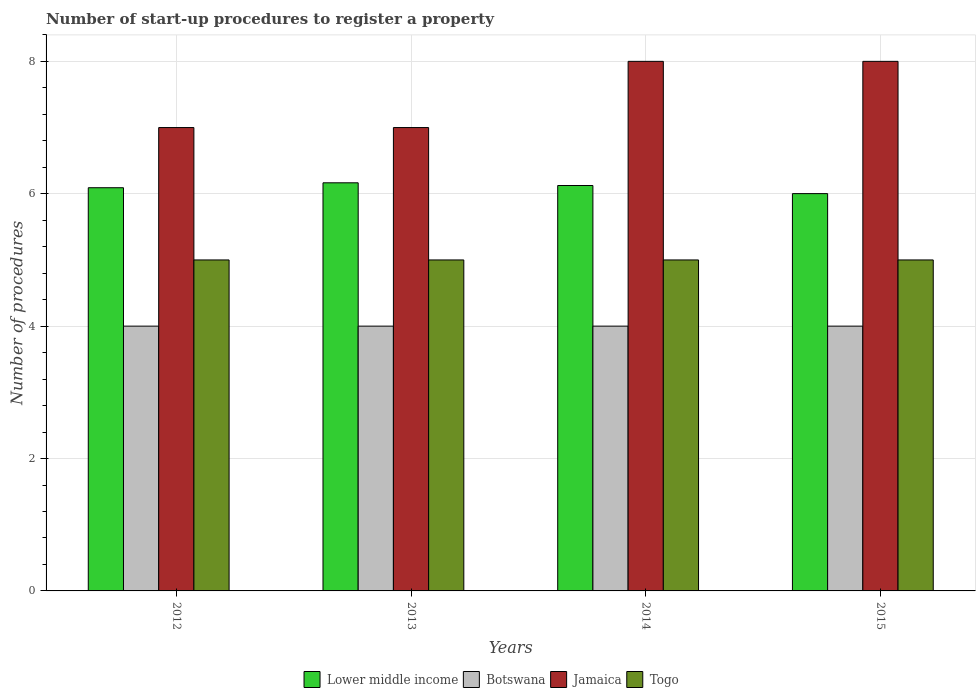How many different coloured bars are there?
Keep it short and to the point. 4. How many groups of bars are there?
Your answer should be compact. 4. Are the number of bars per tick equal to the number of legend labels?
Make the answer very short. Yes. Are the number of bars on each tick of the X-axis equal?
Provide a short and direct response. Yes. How many bars are there on the 2nd tick from the right?
Keep it short and to the point. 4. What is the label of the 1st group of bars from the left?
Your answer should be compact. 2012. What is the number of procedures required to register a property in Togo in 2015?
Keep it short and to the point. 5. Across all years, what is the maximum number of procedures required to register a property in Jamaica?
Provide a succinct answer. 8. Across all years, what is the minimum number of procedures required to register a property in Botswana?
Make the answer very short. 4. In which year was the number of procedures required to register a property in Togo minimum?
Your answer should be very brief. 2012. What is the total number of procedures required to register a property in Lower middle income in the graph?
Give a very brief answer. 24.38. What is the difference between the number of procedures required to register a property in Botswana in 2014 and that in 2015?
Ensure brevity in your answer.  0. What is the difference between the number of procedures required to register a property in Jamaica in 2014 and the number of procedures required to register a property in Botswana in 2013?
Your answer should be very brief. 4. What is the average number of procedures required to register a property in Togo per year?
Keep it short and to the point. 5. In the year 2013, what is the difference between the number of procedures required to register a property in Lower middle income and number of procedures required to register a property in Togo?
Give a very brief answer. 1.17. What is the ratio of the number of procedures required to register a property in Lower middle income in 2012 to that in 2014?
Provide a succinct answer. 0.99. Is the difference between the number of procedures required to register a property in Lower middle income in 2012 and 2013 greater than the difference between the number of procedures required to register a property in Togo in 2012 and 2013?
Offer a very short reply. No. What is the difference between the highest and the second highest number of procedures required to register a property in Botswana?
Keep it short and to the point. 0. What is the difference between the highest and the lowest number of procedures required to register a property in Lower middle income?
Your answer should be compact. 0.16. Is it the case that in every year, the sum of the number of procedures required to register a property in Togo and number of procedures required to register a property in Lower middle income is greater than the sum of number of procedures required to register a property in Jamaica and number of procedures required to register a property in Botswana?
Provide a succinct answer. Yes. What does the 2nd bar from the left in 2015 represents?
Ensure brevity in your answer.  Botswana. What does the 3rd bar from the right in 2012 represents?
Provide a short and direct response. Botswana. Is it the case that in every year, the sum of the number of procedures required to register a property in Togo and number of procedures required to register a property in Lower middle income is greater than the number of procedures required to register a property in Botswana?
Provide a short and direct response. Yes. How many years are there in the graph?
Provide a succinct answer. 4. Are the values on the major ticks of Y-axis written in scientific E-notation?
Make the answer very short. No. Does the graph contain any zero values?
Offer a terse response. No. Where does the legend appear in the graph?
Offer a very short reply. Bottom center. How many legend labels are there?
Offer a terse response. 4. What is the title of the graph?
Your answer should be compact. Number of start-up procedures to register a property. What is the label or title of the X-axis?
Make the answer very short. Years. What is the label or title of the Y-axis?
Offer a terse response. Number of procedures. What is the Number of procedures in Lower middle income in 2012?
Provide a short and direct response. 6.09. What is the Number of procedures of Togo in 2012?
Offer a very short reply. 5. What is the Number of procedures in Lower middle income in 2013?
Offer a terse response. 6.17. What is the Number of procedures in Botswana in 2013?
Your answer should be very brief. 4. What is the Number of procedures of Jamaica in 2013?
Offer a terse response. 7. What is the Number of procedures in Lower middle income in 2014?
Your response must be concise. 6.12. What is the Number of procedures in Botswana in 2014?
Keep it short and to the point. 4. What is the Number of procedures of Togo in 2014?
Offer a very short reply. 5. What is the Number of procedures in Lower middle income in 2015?
Offer a very short reply. 6. What is the Number of procedures in Togo in 2015?
Offer a terse response. 5. Across all years, what is the maximum Number of procedures of Lower middle income?
Your response must be concise. 6.17. Across all years, what is the maximum Number of procedures of Botswana?
Make the answer very short. 4. Across all years, what is the maximum Number of procedures in Togo?
Your response must be concise. 5. Across all years, what is the minimum Number of procedures of Lower middle income?
Your answer should be compact. 6. What is the total Number of procedures in Lower middle income in the graph?
Your answer should be very brief. 24.38. What is the total Number of procedures of Botswana in the graph?
Provide a short and direct response. 16. What is the total Number of procedures of Togo in the graph?
Keep it short and to the point. 20. What is the difference between the Number of procedures in Lower middle income in 2012 and that in 2013?
Your answer should be compact. -0.07. What is the difference between the Number of procedures of Jamaica in 2012 and that in 2013?
Your answer should be compact. 0. What is the difference between the Number of procedures of Lower middle income in 2012 and that in 2014?
Offer a very short reply. -0.03. What is the difference between the Number of procedures in Botswana in 2012 and that in 2014?
Ensure brevity in your answer.  0. What is the difference between the Number of procedures in Togo in 2012 and that in 2014?
Your answer should be compact. 0. What is the difference between the Number of procedures of Lower middle income in 2012 and that in 2015?
Your answer should be compact. 0.09. What is the difference between the Number of procedures of Botswana in 2012 and that in 2015?
Your answer should be very brief. 0. What is the difference between the Number of procedures of Jamaica in 2012 and that in 2015?
Your answer should be very brief. -1. What is the difference between the Number of procedures of Togo in 2012 and that in 2015?
Make the answer very short. 0. What is the difference between the Number of procedures of Lower middle income in 2013 and that in 2014?
Offer a terse response. 0.04. What is the difference between the Number of procedures in Botswana in 2013 and that in 2014?
Your answer should be very brief. 0. What is the difference between the Number of procedures of Jamaica in 2013 and that in 2014?
Provide a short and direct response. -1. What is the difference between the Number of procedures in Lower middle income in 2013 and that in 2015?
Give a very brief answer. 0.16. What is the difference between the Number of procedures in Botswana in 2013 and that in 2015?
Offer a terse response. 0. What is the difference between the Number of procedures of Lower middle income in 2014 and that in 2015?
Offer a terse response. 0.12. What is the difference between the Number of procedures of Botswana in 2014 and that in 2015?
Offer a terse response. 0. What is the difference between the Number of procedures of Jamaica in 2014 and that in 2015?
Make the answer very short. 0. What is the difference between the Number of procedures in Togo in 2014 and that in 2015?
Offer a terse response. 0. What is the difference between the Number of procedures in Lower middle income in 2012 and the Number of procedures in Botswana in 2013?
Offer a very short reply. 2.09. What is the difference between the Number of procedures of Lower middle income in 2012 and the Number of procedures of Jamaica in 2013?
Offer a very short reply. -0.91. What is the difference between the Number of procedures in Lower middle income in 2012 and the Number of procedures in Togo in 2013?
Provide a succinct answer. 1.09. What is the difference between the Number of procedures in Botswana in 2012 and the Number of procedures in Jamaica in 2013?
Give a very brief answer. -3. What is the difference between the Number of procedures of Botswana in 2012 and the Number of procedures of Togo in 2013?
Make the answer very short. -1. What is the difference between the Number of procedures in Lower middle income in 2012 and the Number of procedures in Botswana in 2014?
Provide a succinct answer. 2.09. What is the difference between the Number of procedures in Lower middle income in 2012 and the Number of procedures in Jamaica in 2014?
Offer a very short reply. -1.91. What is the difference between the Number of procedures of Lower middle income in 2012 and the Number of procedures of Togo in 2014?
Your answer should be compact. 1.09. What is the difference between the Number of procedures in Botswana in 2012 and the Number of procedures in Togo in 2014?
Offer a terse response. -1. What is the difference between the Number of procedures of Jamaica in 2012 and the Number of procedures of Togo in 2014?
Your answer should be compact. 2. What is the difference between the Number of procedures of Lower middle income in 2012 and the Number of procedures of Botswana in 2015?
Offer a terse response. 2.09. What is the difference between the Number of procedures in Lower middle income in 2012 and the Number of procedures in Jamaica in 2015?
Give a very brief answer. -1.91. What is the difference between the Number of procedures in Botswana in 2012 and the Number of procedures in Jamaica in 2015?
Provide a short and direct response. -4. What is the difference between the Number of procedures in Botswana in 2012 and the Number of procedures in Togo in 2015?
Your answer should be very brief. -1. What is the difference between the Number of procedures in Jamaica in 2012 and the Number of procedures in Togo in 2015?
Provide a succinct answer. 2. What is the difference between the Number of procedures of Lower middle income in 2013 and the Number of procedures of Botswana in 2014?
Make the answer very short. 2.17. What is the difference between the Number of procedures in Lower middle income in 2013 and the Number of procedures in Jamaica in 2014?
Your response must be concise. -1.83. What is the difference between the Number of procedures of Lower middle income in 2013 and the Number of procedures of Togo in 2014?
Provide a short and direct response. 1.17. What is the difference between the Number of procedures in Lower middle income in 2013 and the Number of procedures in Botswana in 2015?
Offer a very short reply. 2.17. What is the difference between the Number of procedures of Lower middle income in 2013 and the Number of procedures of Jamaica in 2015?
Provide a succinct answer. -1.83. What is the difference between the Number of procedures of Lower middle income in 2013 and the Number of procedures of Togo in 2015?
Ensure brevity in your answer.  1.17. What is the difference between the Number of procedures in Botswana in 2013 and the Number of procedures in Jamaica in 2015?
Your answer should be compact. -4. What is the difference between the Number of procedures in Botswana in 2013 and the Number of procedures in Togo in 2015?
Provide a succinct answer. -1. What is the difference between the Number of procedures in Lower middle income in 2014 and the Number of procedures in Botswana in 2015?
Your answer should be very brief. 2.12. What is the difference between the Number of procedures in Lower middle income in 2014 and the Number of procedures in Jamaica in 2015?
Your response must be concise. -1.88. What is the difference between the Number of procedures of Lower middle income in 2014 and the Number of procedures of Togo in 2015?
Provide a short and direct response. 1.12. What is the difference between the Number of procedures in Jamaica in 2014 and the Number of procedures in Togo in 2015?
Provide a succinct answer. 3. What is the average Number of procedures of Lower middle income per year?
Your answer should be very brief. 6.1. What is the average Number of procedures in Botswana per year?
Ensure brevity in your answer.  4. What is the average Number of procedures in Jamaica per year?
Provide a succinct answer. 7.5. In the year 2012, what is the difference between the Number of procedures in Lower middle income and Number of procedures in Botswana?
Give a very brief answer. 2.09. In the year 2012, what is the difference between the Number of procedures in Lower middle income and Number of procedures in Jamaica?
Your response must be concise. -0.91. In the year 2012, what is the difference between the Number of procedures in Lower middle income and Number of procedures in Togo?
Ensure brevity in your answer.  1.09. In the year 2012, what is the difference between the Number of procedures in Botswana and Number of procedures in Jamaica?
Your answer should be very brief. -3. In the year 2012, what is the difference between the Number of procedures of Jamaica and Number of procedures of Togo?
Offer a very short reply. 2. In the year 2013, what is the difference between the Number of procedures of Lower middle income and Number of procedures of Botswana?
Keep it short and to the point. 2.17. In the year 2013, what is the difference between the Number of procedures in Lower middle income and Number of procedures in Jamaica?
Provide a succinct answer. -0.83. In the year 2013, what is the difference between the Number of procedures of Lower middle income and Number of procedures of Togo?
Provide a short and direct response. 1.17. In the year 2013, what is the difference between the Number of procedures of Jamaica and Number of procedures of Togo?
Give a very brief answer. 2. In the year 2014, what is the difference between the Number of procedures in Lower middle income and Number of procedures in Botswana?
Provide a short and direct response. 2.12. In the year 2014, what is the difference between the Number of procedures in Lower middle income and Number of procedures in Jamaica?
Your answer should be compact. -1.88. In the year 2014, what is the difference between the Number of procedures of Lower middle income and Number of procedures of Togo?
Provide a short and direct response. 1.12. In the year 2014, what is the difference between the Number of procedures of Botswana and Number of procedures of Jamaica?
Give a very brief answer. -4. In the year 2014, what is the difference between the Number of procedures of Botswana and Number of procedures of Togo?
Provide a short and direct response. -1. In the year 2015, what is the difference between the Number of procedures of Lower middle income and Number of procedures of Botswana?
Provide a short and direct response. 2. In the year 2015, what is the difference between the Number of procedures in Lower middle income and Number of procedures in Jamaica?
Your answer should be very brief. -2. In the year 2015, what is the difference between the Number of procedures in Botswana and Number of procedures in Togo?
Keep it short and to the point. -1. In the year 2015, what is the difference between the Number of procedures of Jamaica and Number of procedures of Togo?
Ensure brevity in your answer.  3. What is the ratio of the Number of procedures in Lower middle income in 2012 to that in 2013?
Offer a terse response. 0.99. What is the ratio of the Number of procedures of Botswana in 2012 to that in 2013?
Make the answer very short. 1. What is the ratio of the Number of procedures in Jamaica in 2012 to that in 2014?
Your response must be concise. 0.88. What is the ratio of the Number of procedures of Togo in 2012 to that in 2014?
Ensure brevity in your answer.  1. What is the ratio of the Number of procedures in Lower middle income in 2012 to that in 2015?
Ensure brevity in your answer.  1.01. What is the ratio of the Number of procedures of Botswana in 2012 to that in 2015?
Provide a short and direct response. 1. What is the ratio of the Number of procedures of Togo in 2012 to that in 2015?
Your answer should be compact. 1. What is the ratio of the Number of procedures of Lower middle income in 2013 to that in 2014?
Your response must be concise. 1.01. What is the ratio of the Number of procedures in Botswana in 2013 to that in 2014?
Offer a terse response. 1. What is the ratio of the Number of procedures of Lower middle income in 2013 to that in 2015?
Keep it short and to the point. 1.03. What is the ratio of the Number of procedures in Lower middle income in 2014 to that in 2015?
Your response must be concise. 1.02. What is the ratio of the Number of procedures of Botswana in 2014 to that in 2015?
Ensure brevity in your answer.  1. What is the ratio of the Number of procedures in Togo in 2014 to that in 2015?
Offer a terse response. 1. What is the difference between the highest and the second highest Number of procedures in Lower middle income?
Your response must be concise. 0.04. What is the difference between the highest and the second highest Number of procedures in Botswana?
Your answer should be very brief. 0. What is the difference between the highest and the second highest Number of procedures in Jamaica?
Your answer should be very brief. 0. What is the difference between the highest and the second highest Number of procedures of Togo?
Keep it short and to the point. 0. What is the difference between the highest and the lowest Number of procedures in Lower middle income?
Make the answer very short. 0.16. What is the difference between the highest and the lowest Number of procedures of Togo?
Provide a short and direct response. 0. 